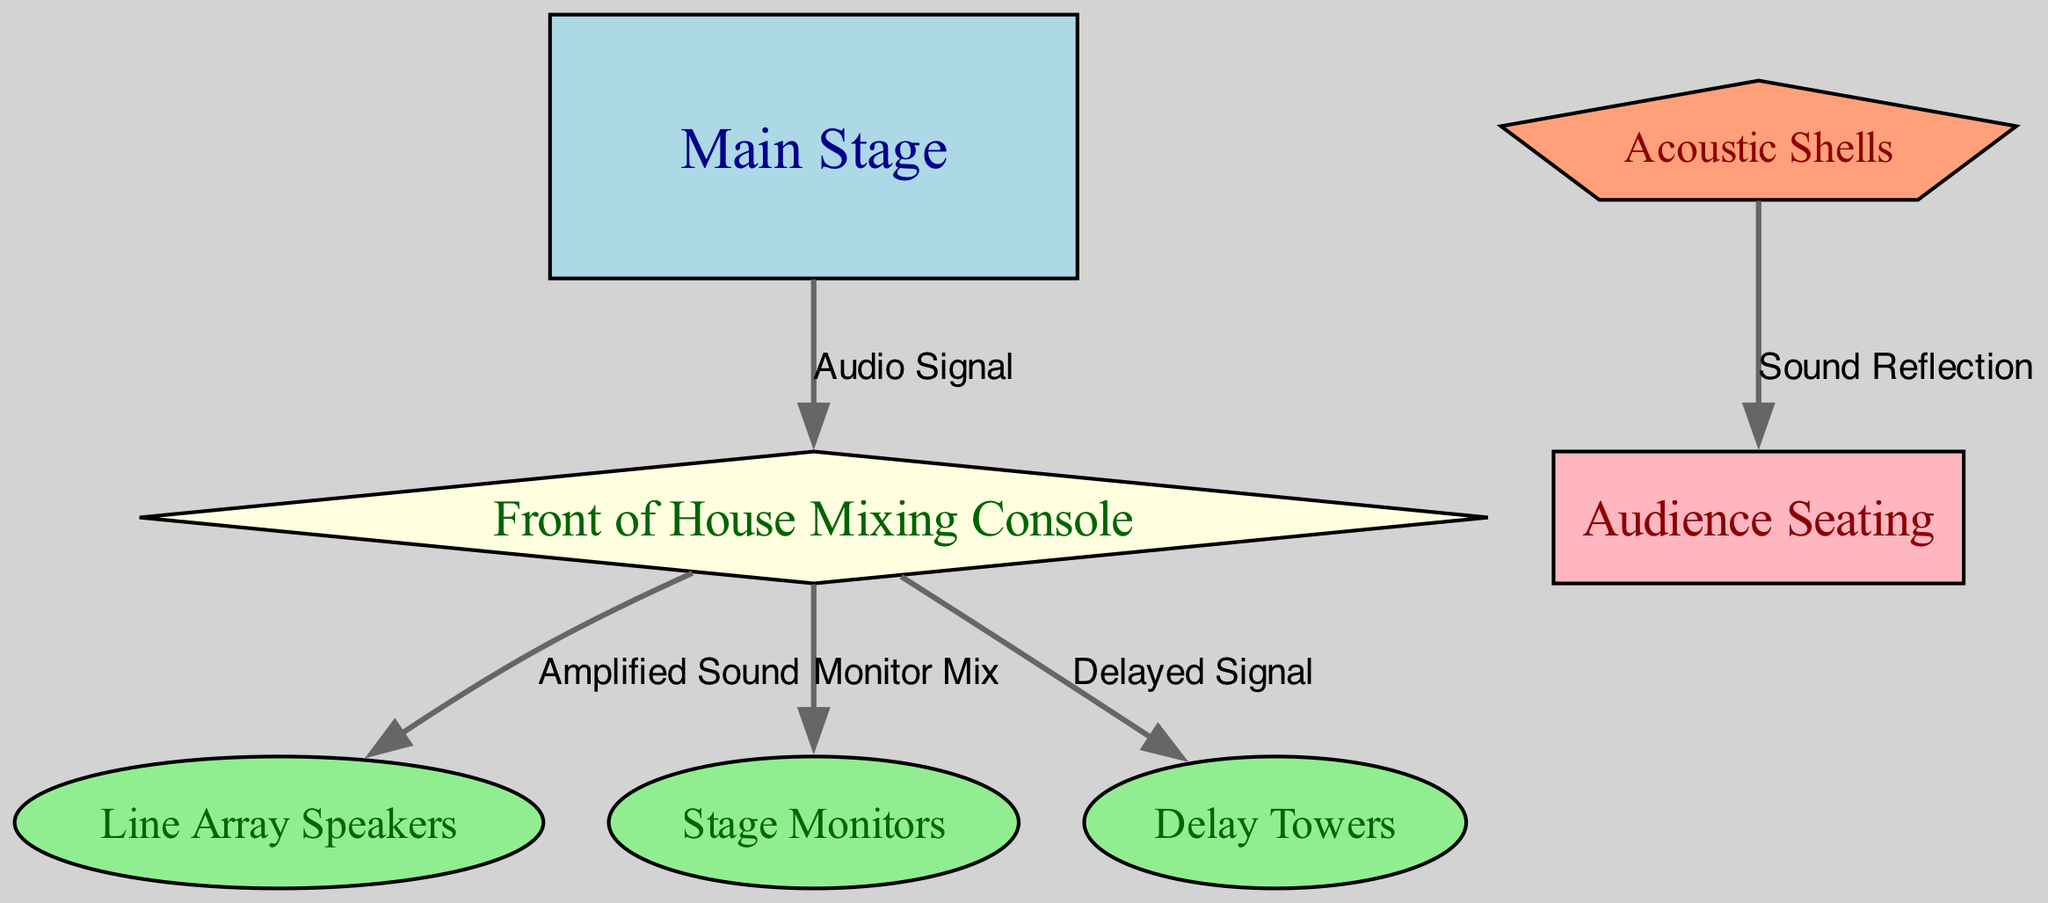What is the total number of nodes in the diagram? The diagram displays several distinct components identified as nodes: Main Stage, Front of House Mixing Console, Line Array Speakers, Stage Monitors, Delay Towers, Acoustic Shells, and Audience Seating. Counting these, there are a total of 7 nodes in the diagram.
Answer: 7 Which node is connected to the Front of House Mixing Console for monitor output? The diagram indicates that the Front of House Mixing Console is connected to the Stage Monitors, specifically labeled as "Monitor Mix." This shows that the audio output designated for stage monitors is sent from the mixing console.
Answer: Stage Monitors What type of edge connects the Main Stage to the Front of House Mixing Console? The edge representing the connection is labeled "Audio Signal." This indicates the flow of the audio signal from the Main Stage to the Front of House Mixing Console, which is critical for sound management during performances.
Answer: Audio Signal How many edges are in the diagram? To determine the total edges, we list each connection: from Main Stage to FOH, from FOH to Speakers, from FOH to Monitors, from FOH to Delay Towers, and from Acoustic Shells to Audience. These count up to a total of 5 edges in the diagram.
Answer: 5 Which node receives the "Sound Reflection" signal? The node that receives the "Sound Reflection" signal is Audience Seating. This connection indicates how sound is reflected and directed towards the audience through the use of acoustic shells in the design.
Answer: Audience Seating What is the purpose of the "Delay Towers" in relation to the Front of House Mixing Console? The "Delay Towers" receive a "Delayed Signal" from the Front of House Mixing Console. This implies that the towers are utilized to distribute sound to areas of the audience that may be further away from the main speakers, ensuring a consistent audio experience overall.
Answer: Delayed Signal What type of node is the Front of House Mixing Console? The Front of House Mixing Console is represented as a diamond-shaped node in the diagram. This shape was chosen to distinguish it from other types of nodes such as the rectangular Main Stage and elliptical speaker nodes.
Answer: Diamond What effect do the Acoustic Shells have on the Audience? The Acoustic Shells facilitate "Sound Reflection," which refers to how they help project and enhance the sound towards the audience, creating a richer auditory experience during performances.
Answer: Sound Reflection 